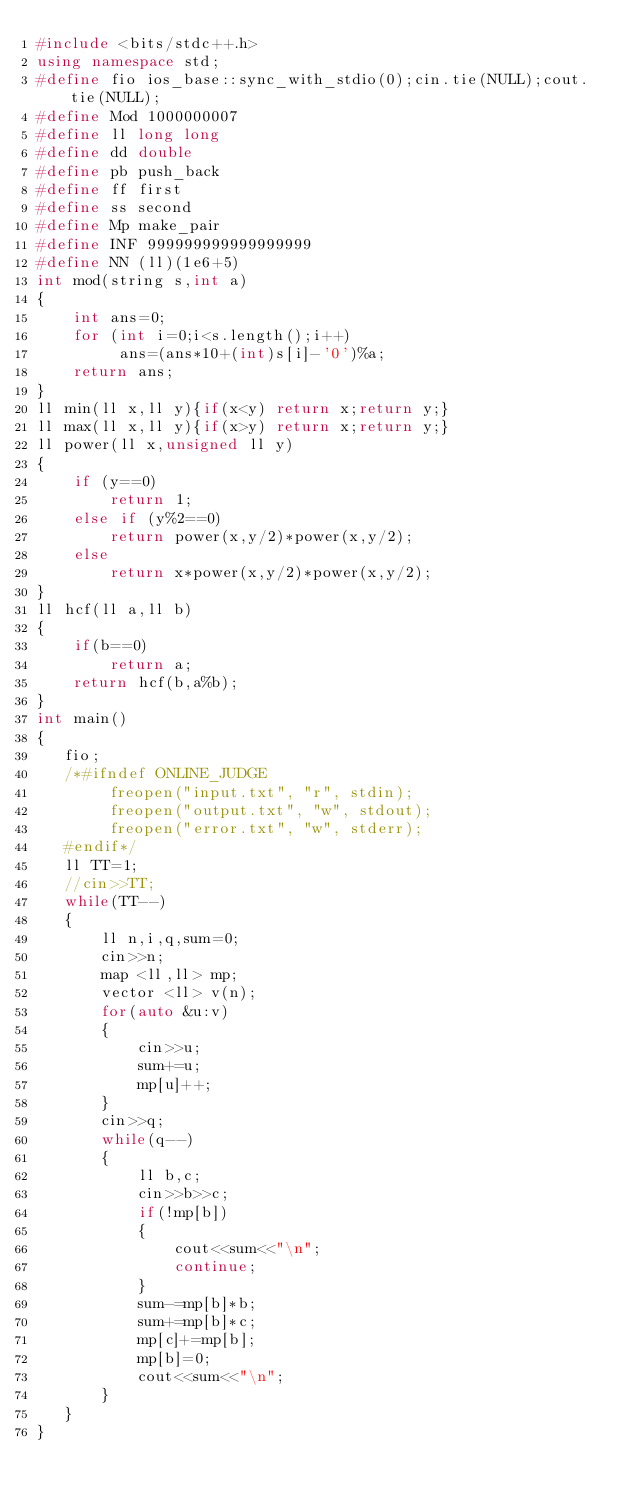Convert code to text. <code><loc_0><loc_0><loc_500><loc_500><_C++_>#include <bits/stdc++.h>
using namespace std;
#define fio ios_base::sync_with_stdio(0);cin.tie(NULL);cout.tie(NULL);
#define Mod 1000000007
#define ll long long
#define dd double
#define pb push_back
#define ff first
#define ss second
#define Mp make_pair
#define INF 999999999999999999
#define NN (ll)(1e6+5)
int mod(string s,int a) 
{ 
    int ans=0; 
    for (int i=0;i<s.length();i++) 
         ans=(ans*10+(int)s[i]-'0')%a; 
    return ans; 
}
ll min(ll x,ll y){if(x<y) return x;return y;}
ll max(ll x,ll y){if(x>y) return x;return y;}
ll power(ll x,unsigned ll y) 
{ 
    if (y==0) 
        return 1; 
    else if (y%2==0) 
        return power(x,y/2)*power(x,y/2); 
    else
        return x*power(x,y/2)*power(x,y/2); 
}
ll hcf(ll a,ll b) 
{ 
    if(b==0) 
        return a; 
    return hcf(b,a%b);  
}
int main()
{
   fio;
   /*#ifndef ONLINE_JUDGE 
    	freopen("input.txt", "r", stdin); 
    	freopen("output.txt", "w", stdout); 
    	freopen("error.txt", "w", stderr); 
   #endif*/
   ll TT=1;
   //cin>>TT;
   while(TT--)
   {    
       ll n,i,q,sum=0;
       cin>>n;
       map <ll,ll> mp;
       vector <ll> v(n);
       for(auto &u:v)
       {
           cin>>u;
           sum+=u;
           mp[u]++;
       }   
       cin>>q;
       while(q--)
       {
           ll b,c;
           cin>>b>>c;
           if(!mp[b])
           {
               cout<<sum<<"\n";
               continue;
           }
           sum-=mp[b]*b;
           sum+=mp[b]*c;
           mp[c]+=mp[b];
           mp[b]=0;
           cout<<sum<<"\n"; 
       }
   }
}</code> 